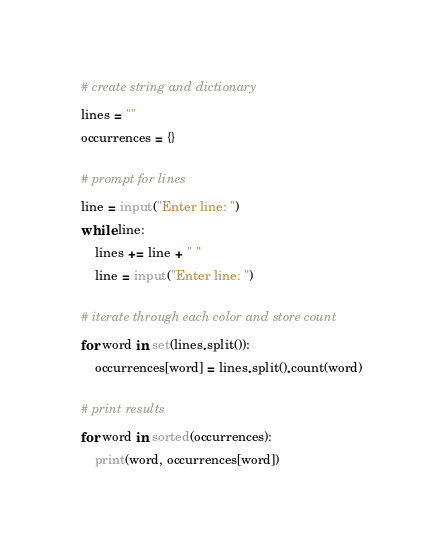<code> <loc_0><loc_0><loc_500><loc_500><_Python_># create string and dictionary
lines = ""
occurrences = {}

# prompt for lines
line = input("Enter line: ")
while line:
    lines += line + " "
    line = input("Enter line: ")

# iterate through each color and store count
for word in set(lines.split()):
    occurrences[word] = lines.split().count(word)

# print results
for word in sorted(occurrences):
    print(word, occurrences[word])
</code> 